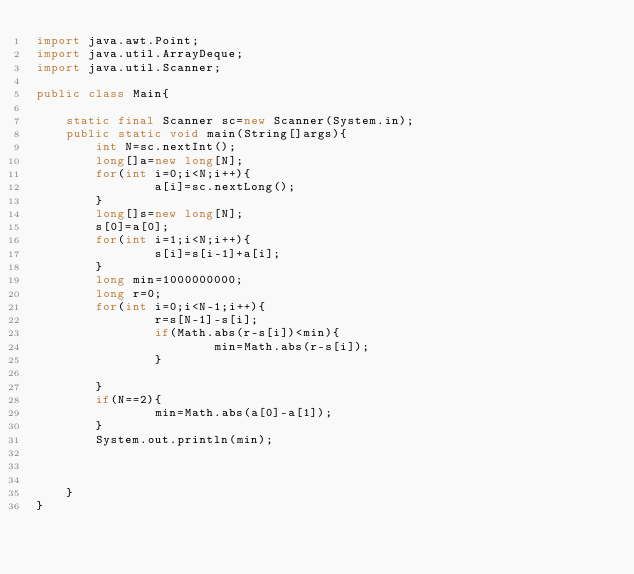Convert code to text. <code><loc_0><loc_0><loc_500><loc_500><_Java_>import java.awt.Point;
import java.util.ArrayDeque;
import java.util.Scanner;
 
public class Main{
	
	static final Scanner sc=new Scanner(System.in);
	public static void main(String[]args){
        int N=sc.nextInt();
        long[]a=new long[N];
        for(int i=0;i<N;i++){
                a[i]=sc.nextLong();
        }
        long[]s=new long[N];
        s[0]=a[0];
        for(int i=1;i<N;i++){
                s[i]=s[i-1]+a[i];
        }
        long min=1000000000;
        long r=0;
        for(int i=0;i<N-1;i++){
                r=s[N-1]-s[i];
                if(Math.abs(r-s[i])<min){
                        min=Math.abs(r-s[i]);
                }

        }
        if(N==2){
                min=Math.abs(a[0]-a[1]);
        }
        System.out.println(min);


		
	}
}
</code> 